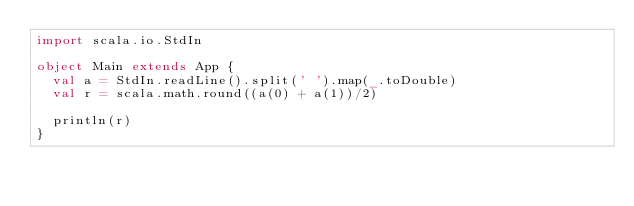<code> <loc_0><loc_0><loc_500><loc_500><_Scala_>import scala.io.StdIn

object Main extends App {
  val a = StdIn.readLine().split(' ').map(_.toDouble)
  val r = scala.math.round((a(0) + a(1))/2)
  
  println(r)
}</code> 